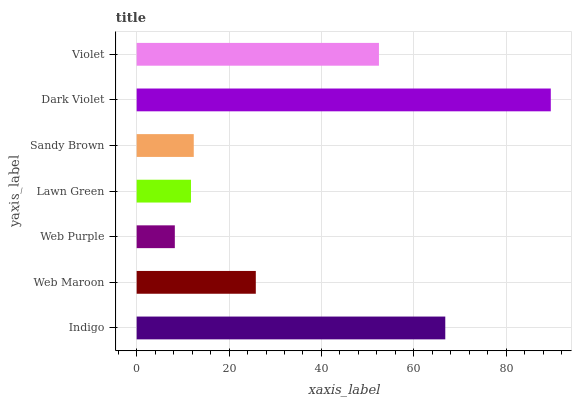Is Web Purple the minimum?
Answer yes or no. Yes. Is Dark Violet the maximum?
Answer yes or no. Yes. Is Web Maroon the minimum?
Answer yes or no. No. Is Web Maroon the maximum?
Answer yes or no. No. Is Indigo greater than Web Maroon?
Answer yes or no. Yes. Is Web Maroon less than Indigo?
Answer yes or no. Yes. Is Web Maroon greater than Indigo?
Answer yes or no. No. Is Indigo less than Web Maroon?
Answer yes or no. No. Is Web Maroon the high median?
Answer yes or no. Yes. Is Web Maroon the low median?
Answer yes or no. Yes. Is Lawn Green the high median?
Answer yes or no. No. Is Lawn Green the low median?
Answer yes or no. No. 